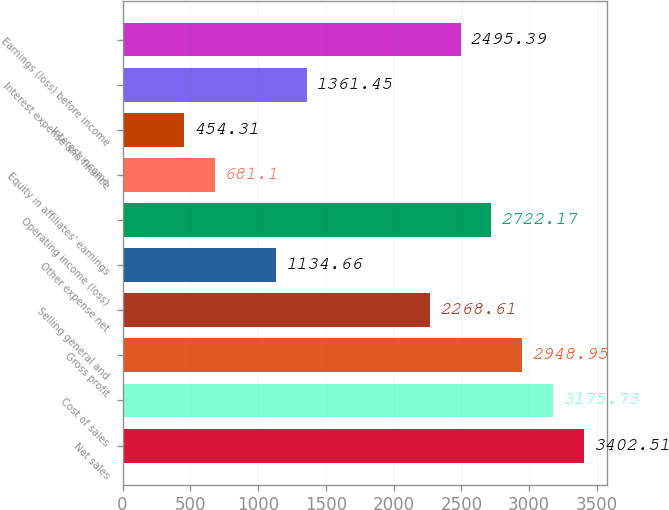<chart> <loc_0><loc_0><loc_500><loc_500><bar_chart><fcel>Net sales<fcel>Cost of sales<fcel>Gross profit<fcel>Selling general and<fcel>Other expense net<fcel>Operating income (loss)<fcel>Equity in affiliates' earnings<fcel>Interest income<fcel>Interest expense and finance<fcel>Earnings (loss) before income<nl><fcel>3402.51<fcel>3175.73<fcel>2948.95<fcel>2268.61<fcel>1134.66<fcel>2722.17<fcel>681.1<fcel>454.31<fcel>1361.45<fcel>2495.39<nl></chart> 